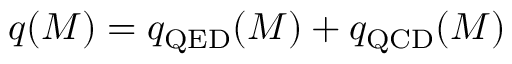<formula> <loc_0><loc_0><loc_500><loc_500>q ( M ) = q _ { Q E D } ( M ) + q _ { Q C D } ( M )</formula> 